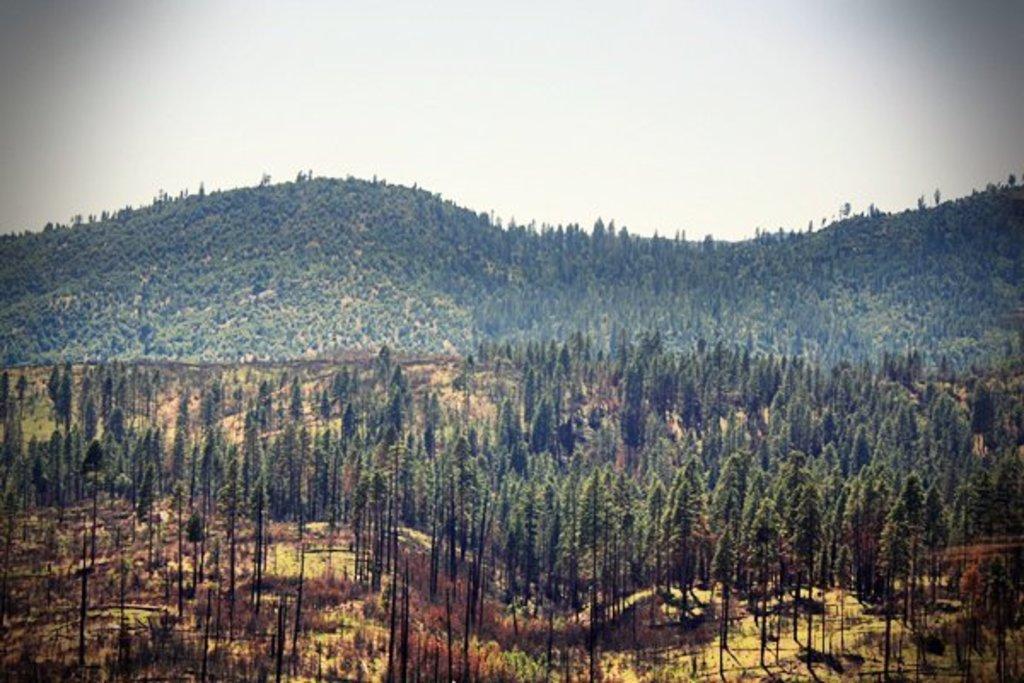Can you describe this image briefly? In this picture we can see few trees and hills. 